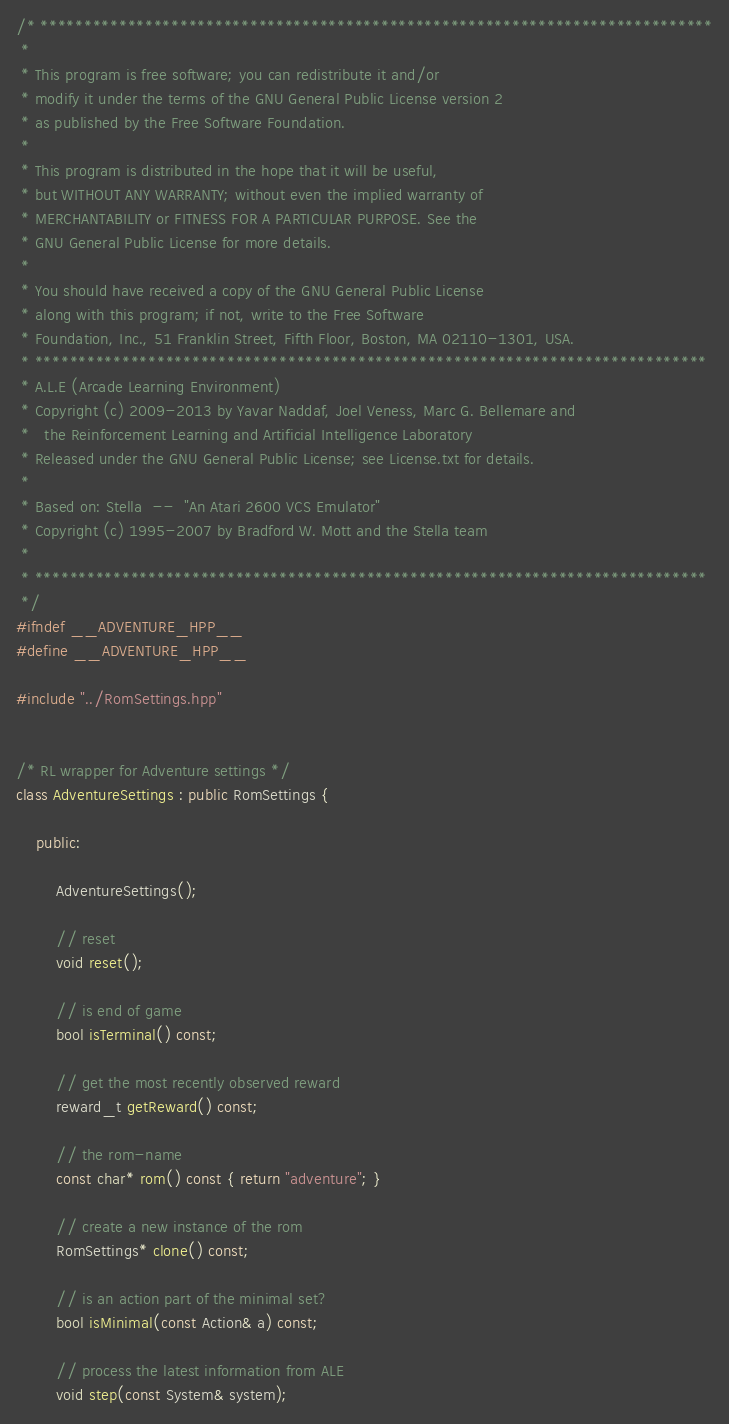Convert code to text. <code><loc_0><loc_0><loc_500><loc_500><_C++_>/* *****************************************************************************
 *
 * This program is free software; you can redistribute it and/or
 * modify it under the terms of the GNU General Public License version 2
 * as published by the Free Software Foundation.
 *
 * This program is distributed in the hope that it will be useful,
 * but WITHOUT ANY WARRANTY; without even the implied warranty of
 * MERCHANTABILITY or FITNESS FOR A PARTICULAR PURPOSE. See the
 * GNU General Public License for more details.
 *
 * You should have received a copy of the GNU General Public License
 * along with this program; if not, write to the Free Software
 * Foundation, Inc., 51 Franklin Street, Fifth Floor, Boston, MA 02110-1301, USA.
 * *****************************************************************************
 * A.L.E (Arcade Learning Environment)
 * Copyright (c) 2009-2013 by Yavar Naddaf, Joel Veness, Marc G. Bellemare and 
 *   the Reinforcement Learning and Artificial Intelligence Laboratory
 * Released under the GNU General Public License; see License.txt for details. 
 *
 * Based on: Stella  --  "An Atari 2600 VCS Emulator"
 * Copyright (c) 1995-2007 by Bradford W. Mott and the Stella team
 *
 * *****************************************************************************
 */
#ifndef __ADVENTURE_HPP__
#define __ADVENTURE_HPP__

#include "../RomSettings.hpp"


/* RL wrapper for Adventure settings */
class AdventureSettings : public RomSettings {

    public:

        AdventureSettings();

        // reset
        void reset();

        // is end of game
        bool isTerminal() const;

        // get the most recently observed reward
        reward_t getReward() const;

        // the rom-name
        const char* rom() const { return "adventure"; }

        // create a new instance of the rom
        RomSettings* clone() const;

        // is an action part of the minimal set?
        bool isMinimal(const Action& a) const;

        // process the latest information from ALE
        void step(const System& system);
</code> 